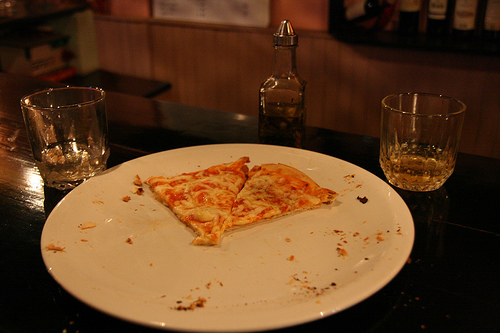Is there any cheese in the image that is orange? No, the cheese visible on the pizza is white, not orange. 